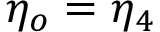<formula> <loc_0><loc_0><loc_500><loc_500>\eta _ { o } = \eta _ { 4 }</formula> 